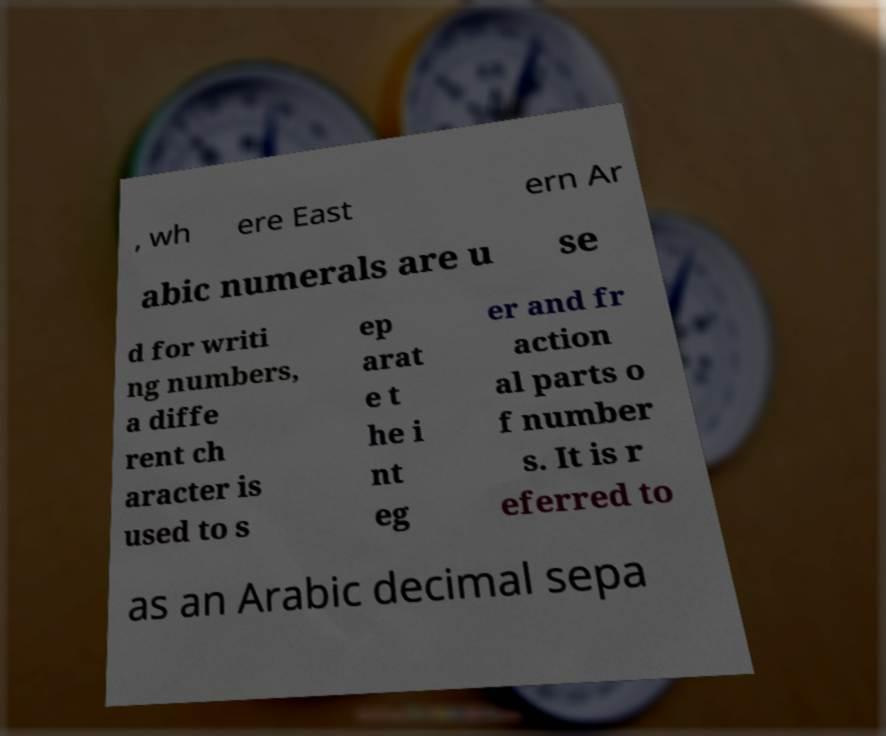There's text embedded in this image that I need extracted. Can you transcribe it verbatim? , wh ere East ern Ar abic numerals are u se d for writi ng numbers, a diffe rent ch aracter is used to s ep arat e t he i nt eg er and fr action al parts o f number s. It is r eferred to as an Arabic decimal sepa 